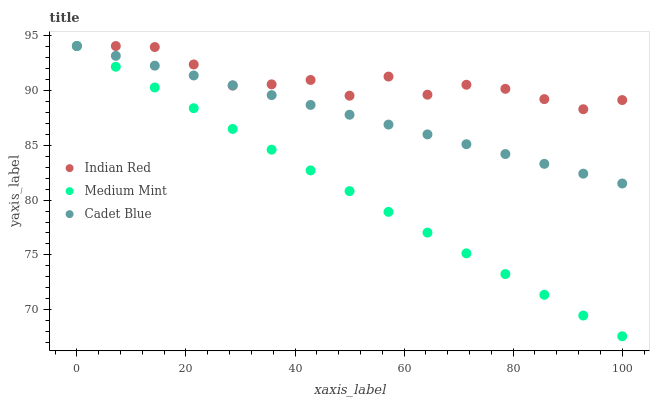Does Medium Mint have the minimum area under the curve?
Answer yes or no. Yes. Does Indian Red have the maximum area under the curve?
Answer yes or no. Yes. Does Cadet Blue have the minimum area under the curve?
Answer yes or no. No. Does Cadet Blue have the maximum area under the curve?
Answer yes or no. No. Is Medium Mint the smoothest?
Answer yes or no. Yes. Is Indian Red the roughest?
Answer yes or no. Yes. Is Cadet Blue the smoothest?
Answer yes or no. No. Is Cadet Blue the roughest?
Answer yes or no. No. Does Medium Mint have the lowest value?
Answer yes or no. Yes. Does Cadet Blue have the lowest value?
Answer yes or no. No. Does Indian Red have the highest value?
Answer yes or no. Yes. Does Medium Mint intersect Cadet Blue?
Answer yes or no. Yes. Is Medium Mint less than Cadet Blue?
Answer yes or no. No. Is Medium Mint greater than Cadet Blue?
Answer yes or no. No. 